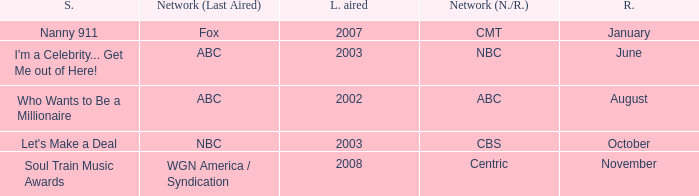When did soul train music awards return? November. 